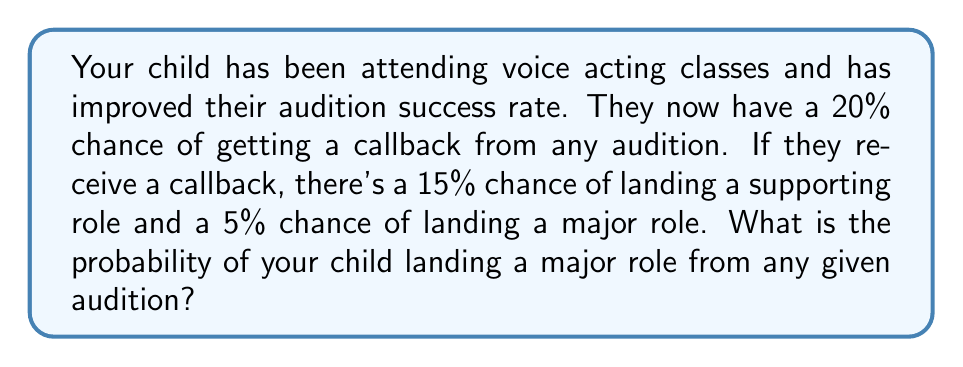Teach me how to tackle this problem. Let's approach this step-by-step:

1) First, we need to understand that landing a major role is a two-step process:
   a) Getting a callback
   b) Landing a major role after the callback

2) We're given the following probabilities:
   - P(Callback) = 20% = 0.20
   - P(Major Role | Callback) = 5% = 0.05

3) To find the probability of both events occurring, we multiply these probabilities:

   $$P(\text{Major Role}) = P(\text{Callback}) \times P(\text{Major Role | Callback})$$

4) Substituting the values:

   $$P(\text{Major Role}) = 0.20 \times 0.05$$

5) Calculating:

   $$P(\text{Major Role}) = 0.01$$

6) Converting to a percentage:

   $$P(\text{Major Role}) = 1\%$$

Therefore, the probability of your child landing a major role from any given audition is 1% or 0.01.
Answer: 1% or 0.01 